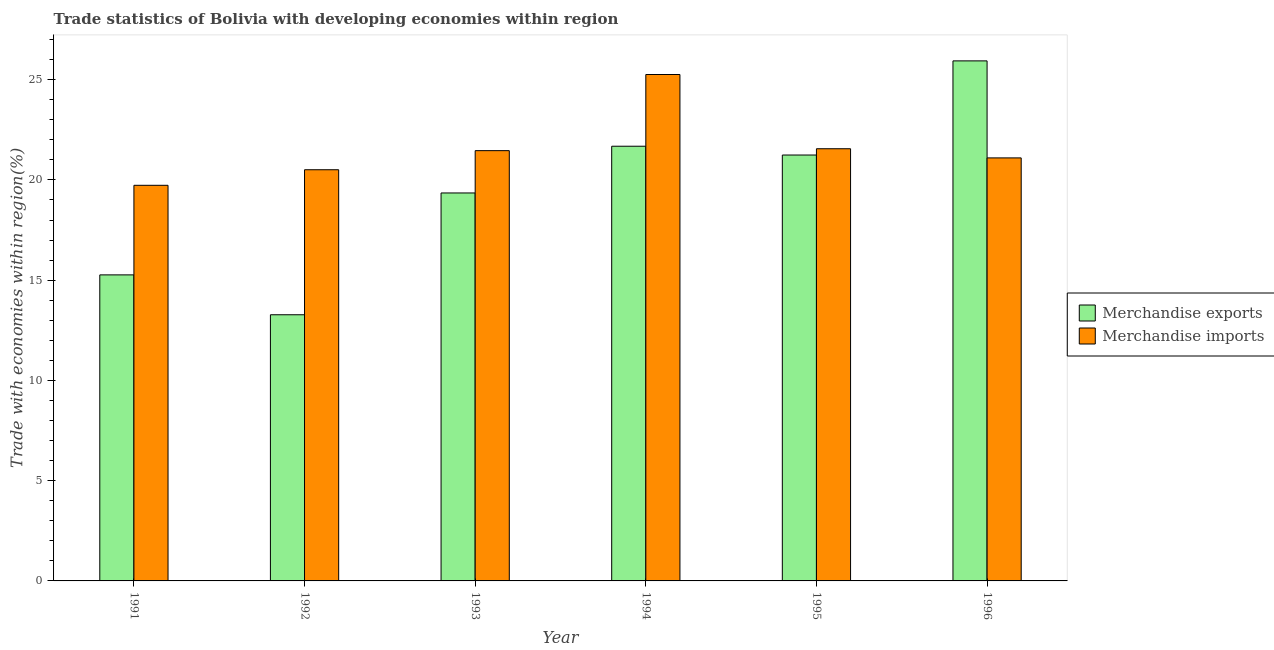How many groups of bars are there?
Give a very brief answer. 6. Are the number of bars per tick equal to the number of legend labels?
Your response must be concise. Yes. In how many cases, is the number of bars for a given year not equal to the number of legend labels?
Make the answer very short. 0. What is the merchandise imports in 1996?
Offer a terse response. 21.1. Across all years, what is the maximum merchandise imports?
Offer a very short reply. 25.26. Across all years, what is the minimum merchandise imports?
Your answer should be compact. 19.73. In which year was the merchandise exports minimum?
Offer a terse response. 1992. What is the total merchandise imports in the graph?
Your answer should be very brief. 129.62. What is the difference between the merchandise imports in 1991 and that in 1992?
Your response must be concise. -0.78. What is the difference between the merchandise imports in 1991 and the merchandise exports in 1993?
Your response must be concise. -1.73. What is the average merchandise exports per year?
Provide a succinct answer. 19.46. In how many years, is the merchandise exports greater than 24 %?
Offer a very short reply. 1. What is the ratio of the merchandise exports in 1991 to that in 1993?
Your response must be concise. 0.79. Is the difference between the merchandise imports in 1991 and 1992 greater than the difference between the merchandise exports in 1991 and 1992?
Your answer should be compact. No. What is the difference between the highest and the second highest merchandise imports?
Make the answer very short. 3.7. What is the difference between the highest and the lowest merchandise exports?
Your answer should be compact. 12.66. What does the 2nd bar from the left in 1993 represents?
Keep it short and to the point. Merchandise imports. How many bars are there?
Your answer should be compact. 12. Are all the bars in the graph horizontal?
Your answer should be very brief. No. Are the values on the major ticks of Y-axis written in scientific E-notation?
Keep it short and to the point. No. Does the graph contain grids?
Make the answer very short. No. Where does the legend appear in the graph?
Your response must be concise. Center right. How are the legend labels stacked?
Give a very brief answer. Vertical. What is the title of the graph?
Give a very brief answer. Trade statistics of Bolivia with developing economies within region. Does "Current education expenditure" appear as one of the legend labels in the graph?
Ensure brevity in your answer.  No. What is the label or title of the X-axis?
Your answer should be very brief. Year. What is the label or title of the Y-axis?
Keep it short and to the point. Trade with economies within region(%). What is the Trade with economies within region(%) in Merchandise exports in 1991?
Offer a terse response. 15.26. What is the Trade with economies within region(%) of Merchandise imports in 1991?
Give a very brief answer. 19.73. What is the Trade with economies within region(%) of Merchandise exports in 1992?
Make the answer very short. 13.28. What is the Trade with economies within region(%) of Merchandise imports in 1992?
Keep it short and to the point. 20.51. What is the Trade with economies within region(%) in Merchandise exports in 1993?
Offer a very short reply. 19.35. What is the Trade with economies within region(%) in Merchandise imports in 1993?
Your response must be concise. 21.46. What is the Trade with economies within region(%) in Merchandise exports in 1994?
Offer a very short reply. 21.68. What is the Trade with economies within region(%) in Merchandise imports in 1994?
Ensure brevity in your answer.  25.26. What is the Trade with economies within region(%) of Merchandise exports in 1995?
Make the answer very short. 21.24. What is the Trade with economies within region(%) of Merchandise imports in 1995?
Give a very brief answer. 21.56. What is the Trade with economies within region(%) in Merchandise exports in 1996?
Make the answer very short. 25.94. What is the Trade with economies within region(%) of Merchandise imports in 1996?
Make the answer very short. 21.1. Across all years, what is the maximum Trade with economies within region(%) of Merchandise exports?
Offer a very short reply. 25.94. Across all years, what is the maximum Trade with economies within region(%) in Merchandise imports?
Provide a succinct answer. 25.26. Across all years, what is the minimum Trade with economies within region(%) of Merchandise exports?
Provide a short and direct response. 13.28. Across all years, what is the minimum Trade with economies within region(%) of Merchandise imports?
Provide a short and direct response. 19.73. What is the total Trade with economies within region(%) of Merchandise exports in the graph?
Your response must be concise. 116.76. What is the total Trade with economies within region(%) in Merchandise imports in the graph?
Your response must be concise. 129.62. What is the difference between the Trade with economies within region(%) of Merchandise exports in 1991 and that in 1992?
Give a very brief answer. 1.99. What is the difference between the Trade with economies within region(%) of Merchandise imports in 1991 and that in 1992?
Provide a succinct answer. -0.78. What is the difference between the Trade with economies within region(%) in Merchandise exports in 1991 and that in 1993?
Make the answer very short. -4.09. What is the difference between the Trade with economies within region(%) in Merchandise imports in 1991 and that in 1993?
Your answer should be compact. -1.73. What is the difference between the Trade with economies within region(%) of Merchandise exports in 1991 and that in 1994?
Provide a short and direct response. -6.42. What is the difference between the Trade with economies within region(%) of Merchandise imports in 1991 and that in 1994?
Your answer should be very brief. -5.53. What is the difference between the Trade with economies within region(%) in Merchandise exports in 1991 and that in 1995?
Make the answer very short. -5.98. What is the difference between the Trade with economies within region(%) of Merchandise imports in 1991 and that in 1995?
Give a very brief answer. -1.82. What is the difference between the Trade with economies within region(%) in Merchandise exports in 1991 and that in 1996?
Offer a very short reply. -10.67. What is the difference between the Trade with economies within region(%) in Merchandise imports in 1991 and that in 1996?
Provide a succinct answer. -1.37. What is the difference between the Trade with economies within region(%) of Merchandise exports in 1992 and that in 1993?
Your answer should be compact. -6.07. What is the difference between the Trade with economies within region(%) of Merchandise imports in 1992 and that in 1993?
Make the answer very short. -0.95. What is the difference between the Trade with economies within region(%) of Merchandise exports in 1992 and that in 1994?
Offer a terse response. -8.41. What is the difference between the Trade with economies within region(%) in Merchandise imports in 1992 and that in 1994?
Offer a terse response. -4.75. What is the difference between the Trade with economies within region(%) in Merchandise exports in 1992 and that in 1995?
Make the answer very short. -7.97. What is the difference between the Trade with economies within region(%) of Merchandise imports in 1992 and that in 1995?
Provide a succinct answer. -1.05. What is the difference between the Trade with economies within region(%) in Merchandise exports in 1992 and that in 1996?
Your response must be concise. -12.66. What is the difference between the Trade with economies within region(%) in Merchandise imports in 1992 and that in 1996?
Keep it short and to the point. -0.59. What is the difference between the Trade with economies within region(%) in Merchandise exports in 1993 and that in 1994?
Offer a very short reply. -2.33. What is the difference between the Trade with economies within region(%) of Merchandise imports in 1993 and that in 1994?
Ensure brevity in your answer.  -3.8. What is the difference between the Trade with economies within region(%) of Merchandise exports in 1993 and that in 1995?
Ensure brevity in your answer.  -1.89. What is the difference between the Trade with economies within region(%) of Merchandise imports in 1993 and that in 1995?
Provide a short and direct response. -0.1. What is the difference between the Trade with economies within region(%) of Merchandise exports in 1993 and that in 1996?
Offer a very short reply. -6.59. What is the difference between the Trade with economies within region(%) of Merchandise imports in 1993 and that in 1996?
Ensure brevity in your answer.  0.36. What is the difference between the Trade with economies within region(%) of Merchandise exports in 1994 and that in 1995?
Keep it short and to the point. 0.44. What is the difference between the Trade with economies within region(%) in Merchandise imports in 1994 and that in 1995?
Keep it short and to the point. 3.7. What is the difference between the Trade with economies within region(%) of Merchandise exports in 1994 and that in 1996?
Ensure brevity in your answer.  -4.26. What is the difference between the Trade with economies within region(%) of Merchandise imports in 1994 and that in 1996?
Give a very brief answer. 4.16. What is the difference between the Trade with economies within region(%) in Merchandise exports in 1995 and that in 1996?
Offer a terse response. -4.7. What is the difference between the Trade with economies within region(%) in Merchandise imports in 1995 and that in 1996?
Offer a terse response. 0.46. What is the difference between the Trade with economies within region(%) in Merchandise exports in 1991 and the Trade with economies within region(%) in Merchandise imports in 1992?
Your answer should be compact. -5.24. What is the difference between the Trade with economies within region(%) in Merchandise exports in 1991 and the Trade with economies within region(%) in Merchandise imports in 1993?
Offer a terse response. -6.2. What is the difference between the Trade with economies within region(%) in Merchandise exports in 1991 and the Trade with economies within region(%) in Merchandise imports in 1994?
Ensure brevity in your answer.  -9.99. What is the difference between the Trade with economies within region(%) in Merchandise exports in 1991 and the Trade with economies within region(%) in Merchandise imports in 1995?
Provide a short and direct response. -6.29. What is the difference between the Trade with economies within region(%) of Merchandise exports in 1991 and the Trade with economies within region(%) of Merchandise imports in 1996?
Keep it short and to the point. -5.83. What is the difference between the Trade with economies within region(%) of Merchandise exports in 1992 and the Trade with economies within region(%) of Merchandise imports in 1993?
Make the answer very short. -8.19. What is the difference between the Trade with economies within region(%) in Merchandise exports in 1992 and the Trade with economies within region(%) in Merchandise imports in 1994?
Give a very brief answer. -11.98. What is the difference between the Trade with economies within region(%) in Merchandise exports in 1992 and the Trade with economies within region(%) in Merchandise imports in 1995?
Your response must be concise. -8.28. What is the difference between the Trade with economies within region(%) in Merchandise exports in 1992 and the Trade with economies within region(%) in Merchandise imports in 1996?
Give a very brief answer. -7.82. What is the difference between the Trade with economies within region(%) in Merchandise exports in 1993 and the Trade with economies within region(%) in Merchandise imports in 1994?
Provide a short and direct response. -5.91. What is the difference between the Trade with economies within region(%) of Merchandise exports in 1993 and the Trade with economies within region(%) of Merchandise imports in 1995?
Keep it short and to the point. -2.21. What is the difference between the Trade with economies within region(%) of Merchandise exports in 1993 and the Trade with economies within region(%) of Merchandise imports in 1996?
Provide a short and direct response. -1.75. What is the difference between the Trade with economies within region(%) in Merchandise exports in 1994 and the Trade with economies within region(%) in Merchandise imports in 1995?
Offer a very short reply. 0.13. What is the difference between the Trade with economies within region(%) of Merchandise exports in 1994 and the Trade with economies within region(%) of Merchandise imports in 1996?
Keep it short and to the point. 0.58. What is the difference between the Trade with economies within region(%) of Merchandise exports in 1995 and the Trade with economies within region(%) of Merchandise imports in 1996?
Offer a very short reply. 0.14. What is the average Trade with economies within region(%) in Merchandise exports per year?
Give a very brief answer. 19.46. What is the average Trade with economies within region(%) in Merchandise imports per year?
Provide a short and direct response. 21.6. In the year 1991, what is the difference between the Trade with economies within region(%) of Merchandise exports and Trade with economies within region(%) of Merchandise imports?
Offer a terse response. -4.47. In the year 1992, what is the difference between the Trade with economies within region(%) in Merchandise exports and Trade with economies within region(%) in Merchandise imports?
Your response must be concise. -7.23. In the year 1993, what is the difference between the Trade with economies within region(%) in Merchandise exports and Trade with economies within region(%) in Merchandise imports?
Ensure brevity in your answer.  -2.11. In the year 1994, what is the difference between the Trade with economies within region(%) in Merchandise exports and Trade with economies within region(%) in Merchandise imports?
Your answer should be compact. -3.58. In the year 1995, what is the difference between the Trade with economies within region(%) of Merchandise exports and Trade with economies within region(%) of Merchandise imports?
Your response must be concise. -0.31. In the year 1996, what is the difference between the Trade with economies within region(%) of Merchandise exports and Trade with economies within region(%) of Merchandise imports?
Ensure brevity in your answer.  4.84. What is the ratio of the Trade with economies within region(%) of Merchandise exports in 1991 to that in 1992?
Provide a short and direct response. 1.15. What is the ratio of the Trade with economies within region(%) of Merchandise imports in 1991 to that in 1992?
Make the answer very short. 0.96. What is the ratio of the Trade with economies within region(%) of Merchandise exports in 1991 to that in 1993?
Make the answer very short. 0.79. What is the ratio of the Trade with economies within region(%) of Merchandise imports in 1991 to that in 1993?
Provide a succinct answer. 0.92. What is the ratio of the Trade with economies within region(%) in Merchandise exports in 1991 to that in 1994?
Make the answer very short. 0.7. What is the ratio of the Trade with economies within region(%) in Merchandise imports in 1991 to that in 1994?
Your response must be concise. 0.78. What is the ratio of the Trade with economies within region(%) of Merchandise exports in 1991 to that in 1995?
Keep it short and to the point. 0.72. What is the ratio of the Trade with economies within region(%) of Merchandise imports in 1991 to that in 1995?
Make the answer very short. 0.92. What is the ratio of the Trade with economies within region(%) in Merchandise exports in 1991 to that in 1996?
Provide a short and direct response. 0.59. What is the ratio of the Trade with economies within region(%) of Merchandise imports in 1991 to that in 1996?
Offer a terse response. 0.94. What is the ratio of the Trade with economies within region(%) in Merchandise exports in 1992 to that in 1993?
Provide a short and direct response. 0.69. What is the ratio of the Trade with economies within region(%) in Merchandise imports in 1992 to that in 1993?
Your answer should be very brief. 0.96. What is the ratio of the Trade with economies within region(%) of Merchandise exports in 1992 to that in 1994?
Ensure brevity in your answer.  0.61. What is the ratio of the Trade with economies within region(%) in Merchandise imports in 1992 to that in 1994?
Give a very brief answer. 0.81. What is the ratio of the Trade with economies within region(%) of Merchandise imports in 1992 to that in 1995?
Provide a short and direct response. 0.95. What is the ratio of the Trade with economies within region(%) in Merchandise exports in 1992 to that in 1996?
Provide a succinct answer. 0.51. What is the ratio of the Trade with economies within region(%) in Merchandise imports in 1992 to that in 1996?
Make the answer very short. 0.97. What is the ratio of the Trade with economies within region(%) in Merchandise exports in 1993 to that in 1994?
Ensure brevity in your answer.  0.89. What is the ratio of the Trade with economies within region(%) of Merchandise imports in 1993 to that in 1994?
Provide a short and direct response. 0.85. What is the ratio of the Trade with economies within region(%) in Merchandise exports in 1993 to that in 1995?
Your response must be concise. 0.91. What is the ratio of the Trade with economies within region(%) in Merchandise imports in 1993 to that in 1995?
Ensure brevity in your answer.  1. What is the ratio of the Trade with economies within region(%) of Merchandise exports in 1993 to that in 1996?
Offer a terse response. 0.75. What is the ratio of the Trade with economies within region(%) of Merchandise imports in 1993 to that in 1996?
Make the answer very short. 1.02. What is the ratio of the Trade with economies within region(%) of Merchandise exports in 1994 to that in 1995?
Make the answer very short. 1.02. What is the ratio of the Trade with economies within region(%) of Merchandise imports in 1994 to that in 1995?
Provide a short and direct response. 1.17. What is the ratio of the Trade with economies within region(%) of Merchandise exports in 1994 to that in 1996?
Your answer should be very brief. 0.84. What is the ratio of the Trade with economies within region(%) in Merchandise imports in 1994 to that in 1996?
Provide a short and direct response. 1.2. What is the ratio of the Trade with economies within region(%) in Merchandise exports in 1995 to that in 1996?
Provide a short and direct response. 0.82. What is the ratio of the Trade with economies within region(%) in Merchandise imports in 1995 to that in 1996?
Ensure brevity in your answer.  1.02. What is the difference between the highest and the second highest Trade with economies within region(%) in Merchandise exports?
Ensure brevity in your answer.  4.26. What is the difference between the highest and the second highest Trade with economies within region(%) of Merchandise imports?
Keep it short and to the point. 3.7. What is the difference between the highest and the lowest Trade with economies within region(%) in Merchandise exports?
Provide a succinct answer. 12.66. What is the difference between the highest and the lowest Trade with economies within region(%) in Merchandise imports?
Make the answer very short. 5.53. 